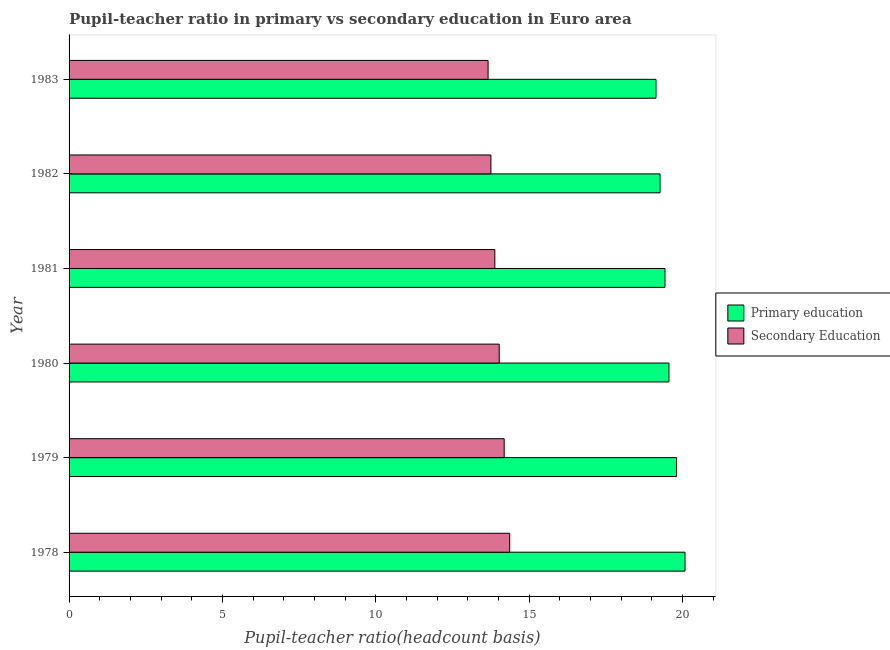Are the number of bars per tick equal to the number of legend labels?
Your answer should be compact. Yes. Are the number of bars on each tick of the Y-axis equal?
Ensure brevity in your answer.  Yes. How many bars are there on the 4th tick from the top?
Ensure brevity in your answer.  2. How many bars are there on the 2nd tick from the bottom?
Your answer should be compact. 2. What is the pupil-teacher ratio in primary education in 1982?
Provide a short and direct response. 19.27. Across all years, what is the maximum pupil-teacher ratio in primary education?
Give a very brief answer. 20.08. Across all years, what is the minimum pupil-teacher ratio in primary education?
Your answer should be very brief. 19.14. In which year was the pupil-teacher ratio in primary education maximum?
Your response must be concise. 1978. In which year was the pupil teacher ratio on secondary education minimum?
Ensure brevity in your answer.  1983. What is the total pupil-teacher ratio in primary education in the graph?
Make the answer very short. 117.27. What is the difference between the pupil teacher ratio on secondary education in 1980 and that in 1982?
Your answer should be compact. 0.27. What is the difference between the pupil teacher ratio on secondary education in 1980 and the pupil-teacher ratio in primary education in 1978?
Your response must be concise. -6.06. What is the average pupil-teacher ratio in primary education per year?
Give a very brief answer. 19.55. In the year 1982, what is the difference between the pupil-teacher ratio in primary education and pupil teacher ratio on secondary education?
Keep it short and to the point. 5.51. In how many years, is the pupil-teacher ratio in primary education greater than 4 ?
Your response must be concise. 6. Is the pupil teacher ratio on secondary education in 1979 less than that in 1983?
Your answer should be very brief. No. Is the difference between the pupil teacher ratio on secondary education in 1978 and 1980 greater than the difference between the pupil-teacher ratio in primary education in 1978 and 1980?
Ensure brevity in your answer.  No. What is the difference between the highest and the second highest pupil-teacher ratio in primary education?
Your answer should be compact. 0.28. What is the difference between the highest and the lowest pupil teacher ratio on secondary education?
Offer a terse response. 0.7. In how many years, is the pupil-teacher ratio in primary education greater than the average pupil-teacher ratio in primary education taken over all years?
Your answer should be very brief. 3. Is the sum of the pupil teacher ratio on secondary education in 1980 and 1983 greater than the maximum pupil-teacher ratio in primary education across all years?
Offer a very short reply. Yes. What does the 1st bar from the top in 1981 represents?
Keep it short and to the point. Secondary Education. How many bars are there?
Offer a terse response. 12. Are all the bars in the graph horizontal?
Keep it short and to the point. Yes. How many years are there in the graph?
Make the answer very short. 6. Are the values on the major ticks of X-axis written in scientific E-notation?
Make the answer very short. No. Does the graph contain any zero values?
Offer a very short reply. No. How are the legend labels stacked?
Make the answer very short. Vertical. What is the title of the graph?
Provide a short and direct response. Pupil-teacher ratio in primary vs secondary education in Euro area. What is the label or title of the X-axis?
Make the answer very short. Pupil-teacher ratio(headcount basis). What is the Pupil-teacher ratio(headcount basis) in Primary education in 1978?
Your answer should be compact. 20.08. What is the Pupil-teacher ratio(headcount basis) in Secondary Education in 1978?
Your response must be concise. 14.36. What is the Pupil-teacher ratio(headcount basis) in Primary education in 1979?
Your answer should be compact. 19.81. What is the Pupil-teacher ratio(headcount basis) in Secondary Education in 1979?
Provide a short and direct response. 14.19. What is the Pupil-teacher ratio(headcount basis) in Primary education in 1980?
Your answer should be very brief. 19.56. What is the Pupil-teacher ratio(headcount basis) of Secondary Education in 1980?
Provide a short and direct response. 14.02. What is the Pupil-teacher ratio(headcount basis) in Primary education in 1981?
Offer a terse response. 19.43. What is the Pupil-teacher ratio(headcount basis) of Secondary Education in 1981?
Ensure brevity in your answer.  13.88. What is the Pupil-teacher ratio(headcount basis) in Primary education in 1982?
Your answer should be compact. 19.27. What is the Pupil-teacher ratio(headcount basis) in Secondary Education in 1982?
Offer a very short reply. 13.75. What is the Pupil-teacher ratio(headcount basis) in Primary education in 1983?
Your answer should be compact. 19.14. What is the Pupil-teacher ratio(headcount basis) of Secondary Education in 1983?
Ensure brevity in your answer.  13.66. Across all years, what is the maximum Pupil-teacher ratio(headcount basis) of Primary education?
Give a very brief answer. 20.08. Across all years, what is the maximum Pupil-teacher ratio(headcount basis) of Secondary Education?
Ensure brevity in your answer.  14.36. Across all years, what is the minimum Pupil-teacher ratio(headcount basis) of Primary education?
Keep it short and to the point. 19.14. Across all years, what is the minimum Pupil-teacher ratio(headcount basis) in Secondary Education?
Give a very brief answer. 13.66. What is the total Pupil-teacher ratio(headcount basis) of Primary education in the graph?
Give a very brief answer. 117.27. What is the total Pupil-teacher ratio(headcount basis) of Secondary Education in the graph?
Your response must be concise. 83.87. What is the difference between the Pupil-teacher ratio(headcount basis) of Primary education in 1978 and that in 1979?
Your answer should be compact. 0.28. What is the difference between the Pupil-teacher ratio(headcount basis) in Secondary Education in 1978 and that in 1979?
Offer a very short reply. 0.18. What is the difference between the Pupil-teacher ratio(headcount basis) of Primary education in 1978 and that in 1980?
Your answer should be very brief. 0.52. What is the difference between the Pupil-teacher ratio(headcount basis) of Secondary Education in 1978 and that in 1980?
Provide a short and direct response. 0.34. What is the difference between the Pupil-teacher ratio(headcount basis) in Primary education in 1978 and that in 1981?
Ensure brevity in your answer.  0.65. What is the difference between the Pupil-teacher ratio(headcount basis) in Secondary Education in 1978 and that in 1981?
Keep it short and to the point. 0.48. What is the difference between the Pupil-teacher ratio(headcount basis) in Primary education in 1978 and that in 1982?
Your response must be concise. 0.81. What is the difference between the Pupil-teacher ratio(headcount basis) in Secondary Education in 1978 and that in 1982?
Offer a very short reply. 0.61. What is the difference between the Pupil-teacher ratio(headcount basis) of Primary education in 1978 and that in 1983?
Provide a short and direct response. 0.95. What is the difference between the Pupil-teacher ratio(headcount basis) in Secondary Education in 1978 and that in 1983?
Offer a terse response. 0.7. What is the difference between the Pupil-teacher ratio(headcount basis) in Primary education in 1979 and that in 1980?
Ensure brevity in your answer.  0.25. What is the difference between the Pupil-teacher ratio(headcount basis) in Secondary Education in 1979 and that in 1980?
Give a very brief answer. 0.16. What is the difference between the Pupil-teacher ratio(headcount basis) in Primary education in 1979 and that in 1981?
Your answer should be compact. 0.38. What is the difference between the Pupil-teacher ratio(headcount basis) in Secondary Education in 1979 and that in 1981?
Ensure brevity in your answer.  0.3. What is the difference between the Pupil-teacher ratio(headcount basis) of Primary education in 1979 and that in 1982?
Make the answer very short. 0.54. What is the difference between the Pupil-teacher ratio(headcount basis) in Secondary Education in 1979 and that in 1982?
Offer a very short reply. 0.43. What is the difference between the Pupil-teacher ratio(headcount basis) in Primary education in 1979 and that in 1983?
Ensure brevity in your answer.  0.67. What is the difference between the Pupil-teacher ratio(headcount basis) in Secondary Education in 1979 and that in 1983?
Your response must be concise. 0.53. What is the difference between the Pupil-teacher ratio(headcount basis) in Primary education in 1980 and that in 1981?
Provide a short and direct response. 0.13. What is the difference between the Pupil-teacher ratio(headcount basis) in Secondary Education in 1980 and that in 1981?
Your answer should be compact. 0.14. What is the difference between the Pupil-teacher ratio(headcount basis) of Primary education in 1980 and that in 1982?
Provide a succinct answer. 0.29. What is the difference between the Pupil-teacher ratio(headcount basis) of Secondary Education in 1980 and that in 1982?
Give a very brief answer. 0.27. What is the difference between the Pupil-teacher ratio(headcount basis) of Primary education in 1980 and that in 1983?
Provide a succinct answer. 0.42. What is the difference between the Pupil-teacher ratio(headcount basis) of Secondary Education in 1980 and that in 1983?
Your answer should be compact. 0.36. What is the difference between the Pupil-teacher ratio(headcount basis) of Primary education in 1981 and that in 1982?
Offer a terse response. 0.16. What is the difference between the Pupil-teacher ratio(headcount basis) of Secondary Education in 1981 and that in 1982?
Provide a short and direct response. 0.13. What is the difference between the Pupil-teacher ratio(headcount basis) of Primary education in 1981 and that in 1983?
Provide a short and direct response. 0.29. What is the difference between the Pupil-teacher ratio(headcount basis) in Secondary Education in 1981 and that in 1983?
Give a very brief answer. 0.22. What is the difference between the Pupil-teacher ratio(headcount basis) in Primary education in 1982 and that in 1983?
Give a very brief answer. 0.13. What is the difference between the Pupil-teacher ratio(headcount basis) in Secondary Education in 1982 and that in 1983?
Make the answer very short. 0.09. What is the difference between the Pupil-teacher ratio(headcount basis) of Primary education in 1978 and the Pupil-teacher ratio(headcount basis) of Secondary Education in 1979?
Your answer should be very brief. 5.9. What is the difference between the Pupil-teacher ratio(headcount basis) in Primary education in 1978 and the Pupil-teacher ratio(headcount basis) in Secondary Education in 1980?
Make the answer very short. 6.06. What is the difference between the Pupil-teacher ratio(headcount basis) in Primary education in 1978 and the Pupil-teacher ratio(headcount basis) in Secondary Education in 1981?
Keep it short and to the point. 6.2. What is the difference between the Pupil-teacher ratio(headcount basis) in Primary education in 1978 and the Pupil-teacher ratio(headcount basis) in Secondary Education in 1982?
Offer a terse response. 6.33. What is the difference between the Pupil-teacher ratio(headcount basis) in Primary education in 1978 and the Pupil-teacher ratio(headcount basis) in Secondary Education in 1983?
Give a very brief answer. 6.42. What is the difference between the Pupil-teacher ratio(headcount basis) of Primary education in 1979 and the Pupil-teacher ratio(headcount basis) of Secondary Education in 1980?
Provide a short and direct response. 5.78. What is the difference between the Pupil-teacher ratio(headcount basis) in Primary education in 1979 and the Pupil-teacher ratio(headcount basis) in Secondary Education in 1981?
Your answer should be very brief. 5.92. What is the difference between the Pupil-teacher ratio(headcount basis) of Primary education in 1979 and the Pupil-teacher ratio(headcount basis) of Secondary Education in 1982?
Your answer should be very brief. 6.05. What is the difference between the Pupil-teacher ratio(headcount basis) in Primary education in 1979 and the Pupil-teacher ratio(headcount basis) in Secondary Education in 1983?
Provide a short and direct response. 6.15. What is the difference between the Pupil-teacher ratio(headcount basis) of Primary education in 1980 and the Pupil-teacher ratio(headcount basis) of Secondary Education in 1981?
Your response must be concise. 5.68. What is the difference between the Pupil-teacher ratio(headcount basis) in Primary education in 1980 and the Pupil-teacher ratio(headcount basis) in Secondary Education in 1982?
Ensure brevity in your answer.  5.8. What is the difference between the Pupil-teacher ratio(headcount basis) of Primary education in 1980 and the Pupil-teacher ratio(headcount basis) of Secondary Education in 1983?
Provide a short and direct response. 5.9. What is the difference between the Pupil-teacher ratio(headcount basis) in Primary education in 1981 and the Pupil-teacher ratio(headcount basis) in Secondary Education in 1982?
Keep it short and to the point. 5.68. What is the difference between the Pupil-teacher ratio(headcount basis) in Primary education in 1981 and the Pupil-teacher ratio(headcount basis) in Secondary Education in 1983?
Your answer should be compact. 5.77. What is the difference between the Pupil-teacher ratio(headcount basis) in Primary education in 1982 and the Pupil-teacher ratio(headcount basis) in Secondary Education in 1983?
Offer a terse response. 5.61. What is the average Pupil-teacher ratio(headcount basis) in Primary education per year?
Offer a terse response. 19.55. What is the average Pupil-teacher ratio(headcount basis) of Secondary Education per year?
Make the answer very short. 13.98. In the year 1978, what is the difference between the Pupil-teacher ratio(headcount basis) of Primary education and Pupil-teacher ratio(headcount basis) of Secondary Education?
Your response must be concise. 5.72. In the year 1979, what is the difference between the Pupil-teacher ratio(headcount basis) in Primary education and Pupil-teacher ratio(headcount basis) in Secondary Education?
Make the answer very short. 5.62. In the year 1980, what is the difference between the Pupil-teacher ratio(headcount basis) of Primary education and Pupil-teacher ratio(headcount basis) of Secondary Education?
Keep it short and to the point. 5.53. In the year 1981, what is the difference between the Pupil-teacher ratio(headcount basis) in Primary education and Pupil-teacher ratio(headcount basis) in Secondary Education?
Provide a short and direct response. 5.55. In the year 1982, what is the difference between the Pupil-teacher ratio(headcount basis) in Primary education and Pupil-teacher ratio(headcount basis) in Secondary Education?
Keep it short and to the point. 5.51. In the year 1983, what is the difference between the Pupil-teacher ratio(headcount basis) in Primary education and Pupil-teacher ratio(headcount basis) in Secondary Education?
Keep it short and to the point. 5.47. What is the ratio of the Pupil-teacher ratio(headcount basis) in Primary education in 1978 to that in 1979?
Make the answer very short. 1.01. What is the ratio of the Pupil-teacher ratio(headcount basis) in Secondary Education in 1978 to that in 1979?
Give a very brief answer. 1.01. What is the ratio of the Pupil-teacher ratio(headcount basis) in Primary education in 1978 to that in 1980?
Provide a succinct answer. 1.03. What is the ratio of the Pupil-teacher ratio(headcount basis) in Secondary Education in 1978 to that in 1980?
Your answer should be very brief. 1.02. What is the ratio of the Pupil-teacher ratio(headcount basis) of Primary education in 1978 to that in 1981?
Keep it short and to the point. 1.03. What is the ratio of the Pupil-teacher ratio(headcount basis) in Secondary Education in 1978 to that in 1981?
Your answer should be compact. 1.03. What is the ratio of the Pupil-teacher ratio(headcount basis) of Primary education in 1978 to that in 1982?
Offer a very short reply. 1.04. What is the ratio of the Pupil-teacher ratio(headcount basis) in Secondary Education in 1978 to that in 1982?
Your answer should be very brief. 1.04. What is the ratio of the Pupil-teacher ratio(headcount basis) of Primary education in 1978 to that in 1983?
Provide a succinct answer. 1.05. What is the ratio of the Pupil-teacher ratio(headcount basis) in Secondary Education in 1978 to that in 1983?
Ensure brevity in your answer.  1.05. What is the ratio of the Pupil-teacher ratio(headcount basis) in Primary education in 1979 to that in 1980?
Provide a short and direct response. 1.01. What is the ratio of the Pupil-teacher ratio(headcount basis) in Secondary Education in 1979 to that in 1980?
Your answer should be compact. 1.01. What is the ratio of the Pupil-teacher ratio(headcount basis) of Primary education in 1979 to that in 1981?
Make the answer very short. 1.02. What is the ratio of the Pupil-teacher ratio(headcount basis) in Primary education in 1979 to that in 1982?
Give a very brief answer. 1.03. What is the ratio of the Pupil-teacher ratio(headcount basis) of Secondary Education in 1979 to that in 1982?
Offer a terse response. 1.03. What is the ratio of the Pupil-teacher ratio(headcount basis) in Primary education in 1979 to that in 1983?
Provide a succinct answer. 1.04. What is the ratio of the Pupil-teacher ratio(headcount basis) in Primary education in 1980 to that in 1981?
Offer a very short reply. 1.01. What is the ratio of the Pupil-teacher ratio(headcount basis) in Secondary Education in 1980 to that in 1981?
Your response must be concise. 1.01. What is the ratio of the Pupil-teacher ratio(headcount basis) in Primary education in 1980 to that in 1982?
Offer a terse response. 1.02. What is the ratio of the Pupil-teacher ratio(headcount basis) of Secondary Education in 1980 to that in 1982?
Your answer should be compact. 1.02. What is the ratio of the Pupil-teacher ratio(headcount basis) in Primary education in 1980 to that in 1983?
Provide a succinct answer. 1.02. What is the ratio of the Pupil-teacher ratio(headcount basis) in Secondary Education in 1980 to that in 1983?
Your answer should be very brief. 1.03. What is the ratio of the Pupil-teacher ratio(headcount basis) in Primary education in 1981 to that in 1982?
Make the answer very short. 1.01. What is the ratio of the Pupil-teacher ratio(headcount basis) of Secondary Education in 1981 to that in 1982?
Make the answer very short. 1.01. What is the ratio of the Pupil-teacher ratio(headcount basis) in Primary education in 1981 to that in 1983?
Give a very brief answer. 1.02. What is the ratio of the Pupil-teacher ratio(headcount basis) of Secondary Education in 1981 to that in 1983?
Your answer should be compact. 1.02. What is the difference between the highest and the second highest Pupil-teacher ratio(headcount basis) of Primary education?
Your response must be concise. 0.28. What is the difference between the highest and the second highest Pupil-teacher ratio(headcount basis) in Secondary Education?
Ensure brevity in your answer.  0.18. What is the difference between the highest and the lowest Pupil-teacher ratio(headcount basis) of Primary education?
Ensure brevity in your answer.  0.95. What is the difference between the highest and the lowest Pupil-teacher ratio(headcount basis) in Secondary Education?
Make the answer very short. 0.7. 